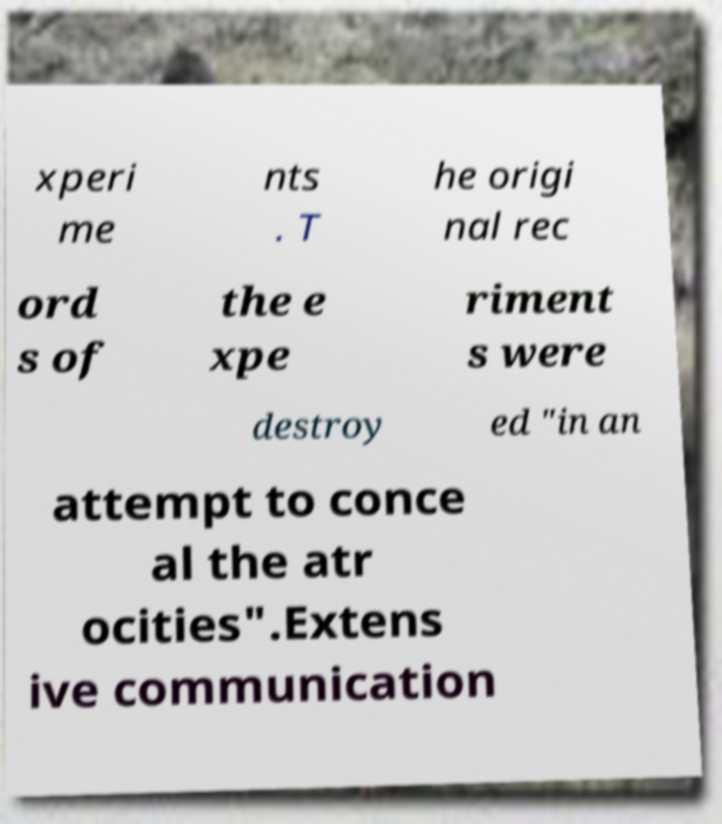Can you read and provide the text displayed in the image?This photo seems to have some interesting text. Can you extract and type it out for me? xperi me nts . T he origi nal rec ord s of the e xpe riment s were destroy ed "in an attempt to conce al the atr ocities".Extens ive communication 